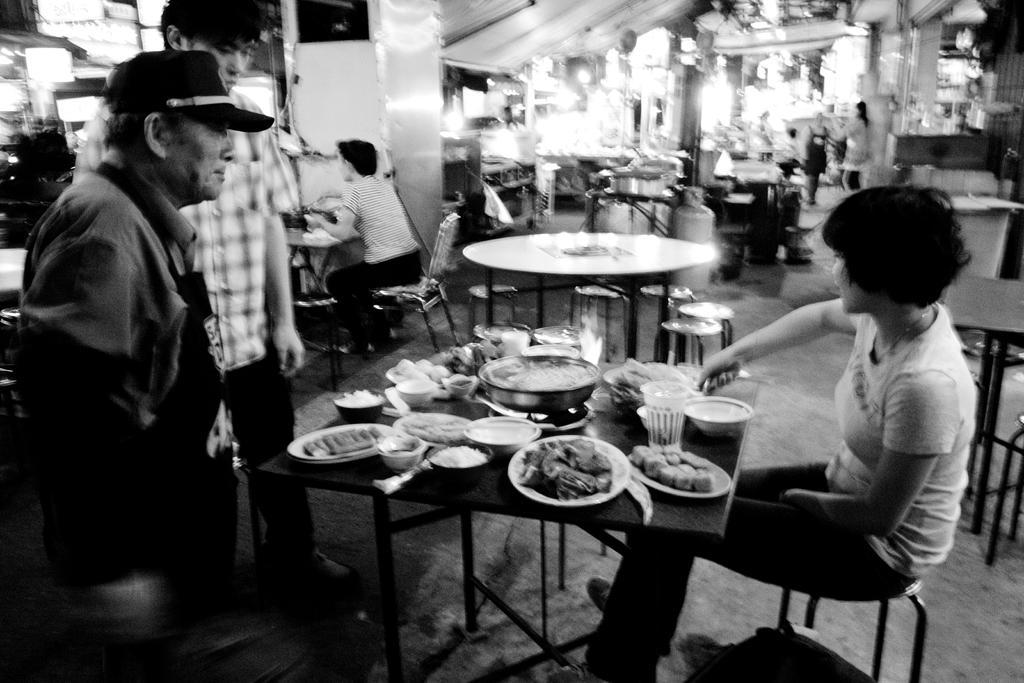Please provide a concise description of this image. This is a black and white picture, there are a group of people sitting on a chair in front of these people there is a table on the table there are plates and food items. Background of this people is a wall. 